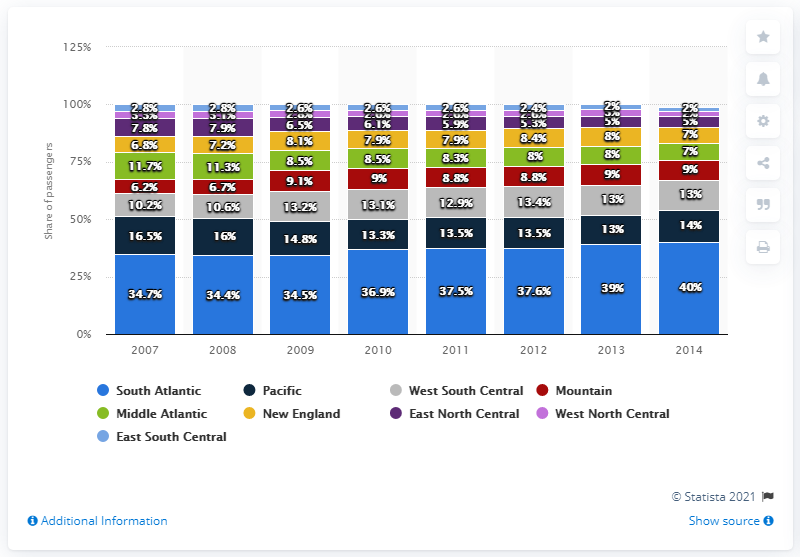Give some essential details in this illustration. The South Atlantic region has the highest percentage of share of passengers among all regions. In the year 2014, the share of passengers in the New England and Middle Atlantic regions of the United States accounted for a total of 14% of the national passenger market. 